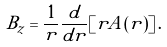<formula> <loc_0><loc_0><loc_500><loc_500>B _ { z } = \frac { 1 } { r } \frac { d } { d r } [ r A ( r ) ] \, .</formula> 